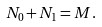Convert formula to latex. <formula><loc_0><loc_0><loc_500><loc_500>N _ { 0 } + N _ { 1 } = M .</formula> 